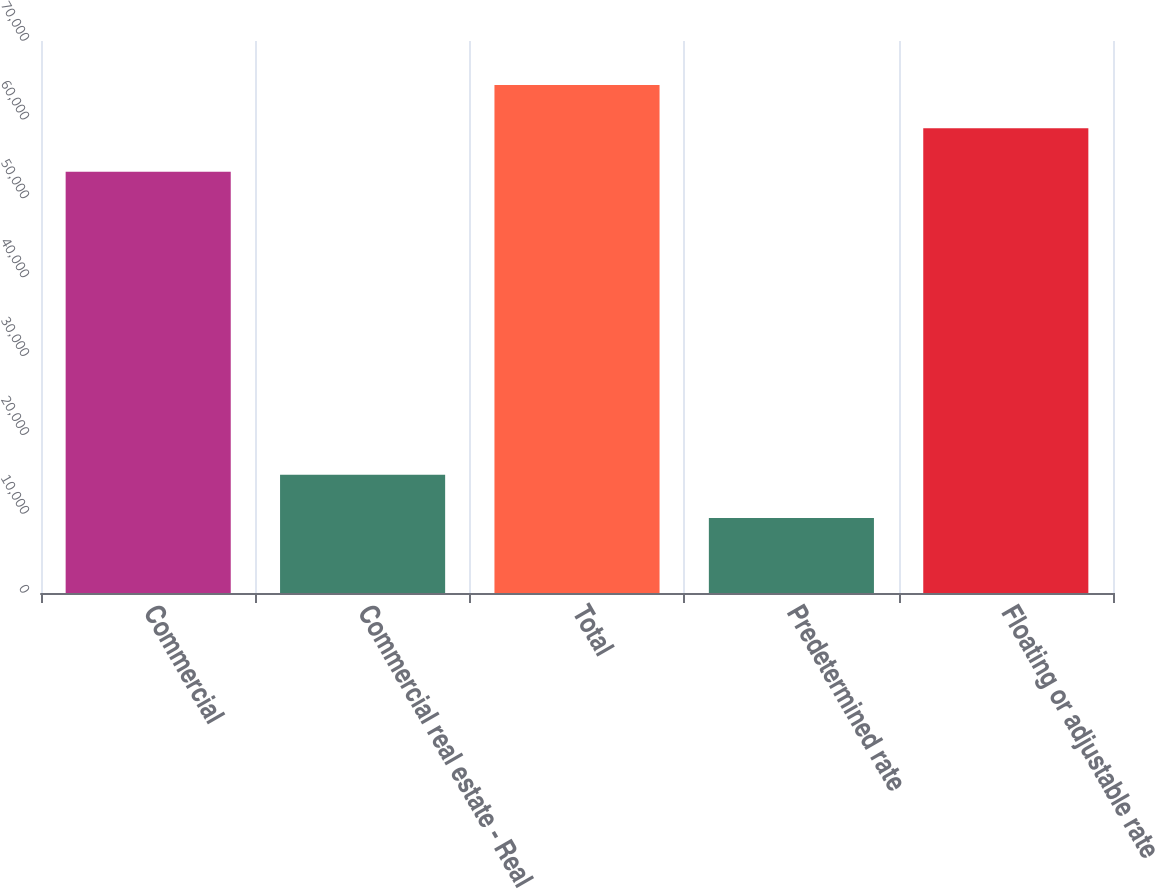Convert chart. <chart><loc_0><loc_0><loc_500><loc_500><bar_chart><fcel>Commercial<fcel>Commercial real estate - Real<fcel>Total<fcel>Predetermined rate<fcel>Floating or adjustable rate<nl><fcel>53434<fcel>14994.9<fcel>64409.8<fcel>9507<fcel>58921.9<nl></chart> 